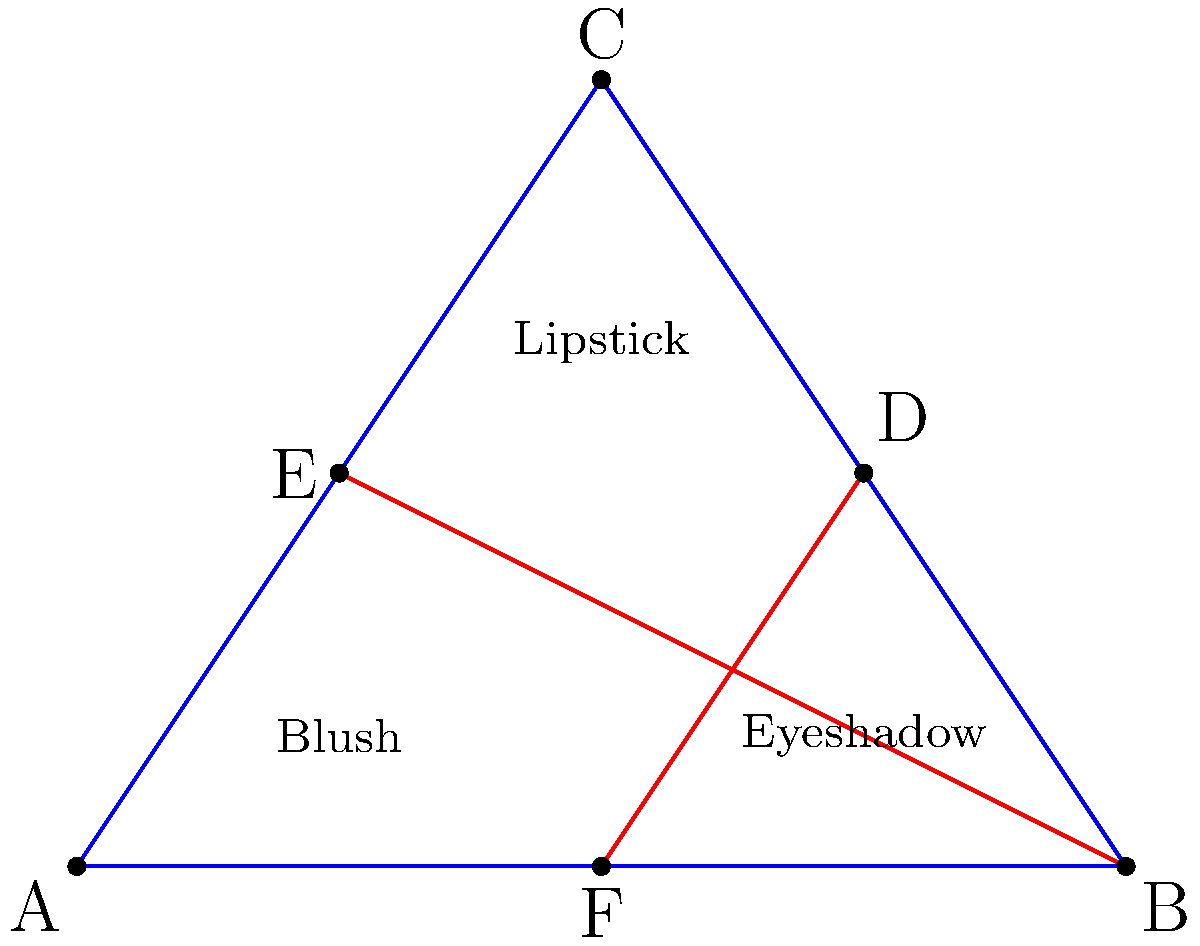In this fabulous makeup palette arrangement, we've created a triangular masterpiece! If the line connecting the midpoints of the "Lipstick-Eyeshadow" side and the "Blush-Lipstick" side is congruent to the line from point B to the midpoint of the "Blush-Lipstick" side, what witty conclusion can we draw about the original triangle ABC? Let's break this down step-by-step, with a touch of glamour:

1) In our makeup triangle, we have:
   - D: midpoint of BC (Lipstick-Eyeshadow)
   - E: midpoint of AC (Blush-Lipstick)
   - F: midpoint of AB (Blush-Eyeshadow)

2) We're told that DF ≅ BE. This is our key to unlocking the mystery!

3) In any triangle, the line segment joining the midpoints of two sides is parallel to the third side and half the length. So:
   - DF || AC and DF = 1/2 AC
   - BE || AC and BE = 1/2 AC

4) Since DF ≅ BE, and they're both parallel to AC, we can conclude that DF = BE = 1/2 AC.

5) Now, here's where it gets interesting! In a triangle, if a line segment from a vertex to the midpoint of the opposite side is equal to half that side, the triangle must be right-angled at that vertex.

6) In our case, BE = 1/2 AC, which means our triangle is right-angled at B!

7) Therefore, our glamorous triangle ABC is actually a right triangle, with the right angle at B (the Eyeshadow corner)!

So, we've discovered that our makeup palette arrangement isn't just beautiful, it's also a right triangle in disguise! Who knew geometry could be so fabulous?
Answer: ABC is a right triangle with $\angle B = 90°$ 